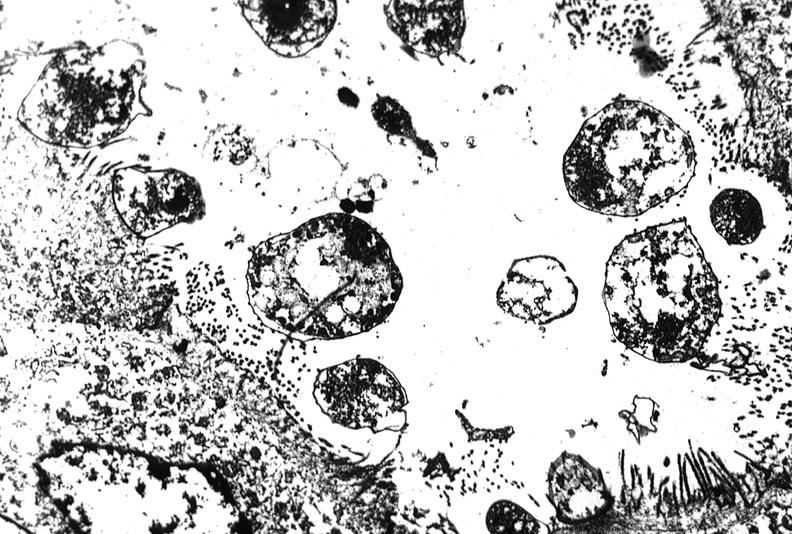does pus in test tube show colon biopsy, cryptosporidia?
Answer the question using a single word or phrase. No 